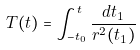Convert formula to latex. <formula><loc_0><loc_0><loc_500><loc_500>T ( t ) = \int ^ { t } _ { - t _ { 0 } } \frac { d t _ { 1 } } { r ^ { 2 } ( t _ { 1 } ) }</formula> 